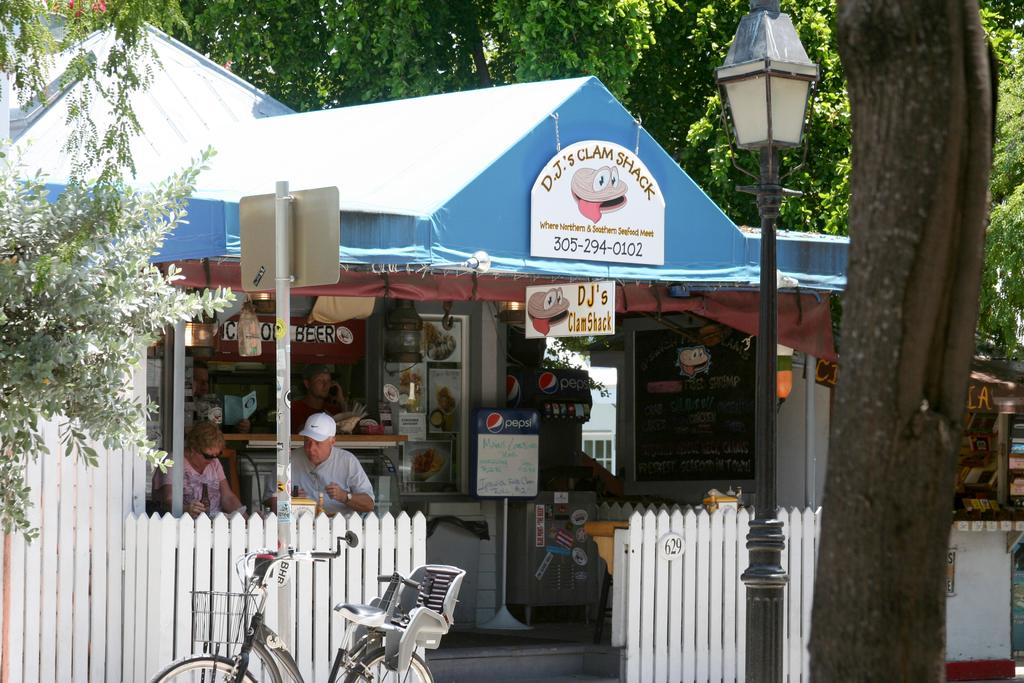What is parked near the fence in the image? There is a bicycle parked near the fence in the image. What structure can be seen in the image with a light source on top? There is a light pole in the image with a board attached to it. What type of vegetation is present in the image? There are trees in the image. What are the people in the image doing? There are people sitting in the image. What type of establishment can be seen in the image? There is a food court in the image. What type of temporary shelter is present in the image? There is a tent in the image. What type of building can be seen in the background of the image? There is a wooden house in the background of the image. Where is the dock located in the image? There is no dock present in the image. What type of waste is being disposed of in the image? There is no waste disposal activity depicted in the image. 